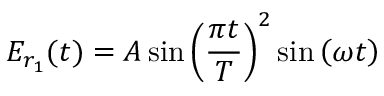Convert formula to latex. <formula><loc_0><loc_0><loc_500><loc_500>{ E } _ { r _ { 1 } } ( t ) = A \sin \left ( \frac { \pi t } { T } \right ) ^ { 2 } \sin \left ( \omega t \right )</formula> 